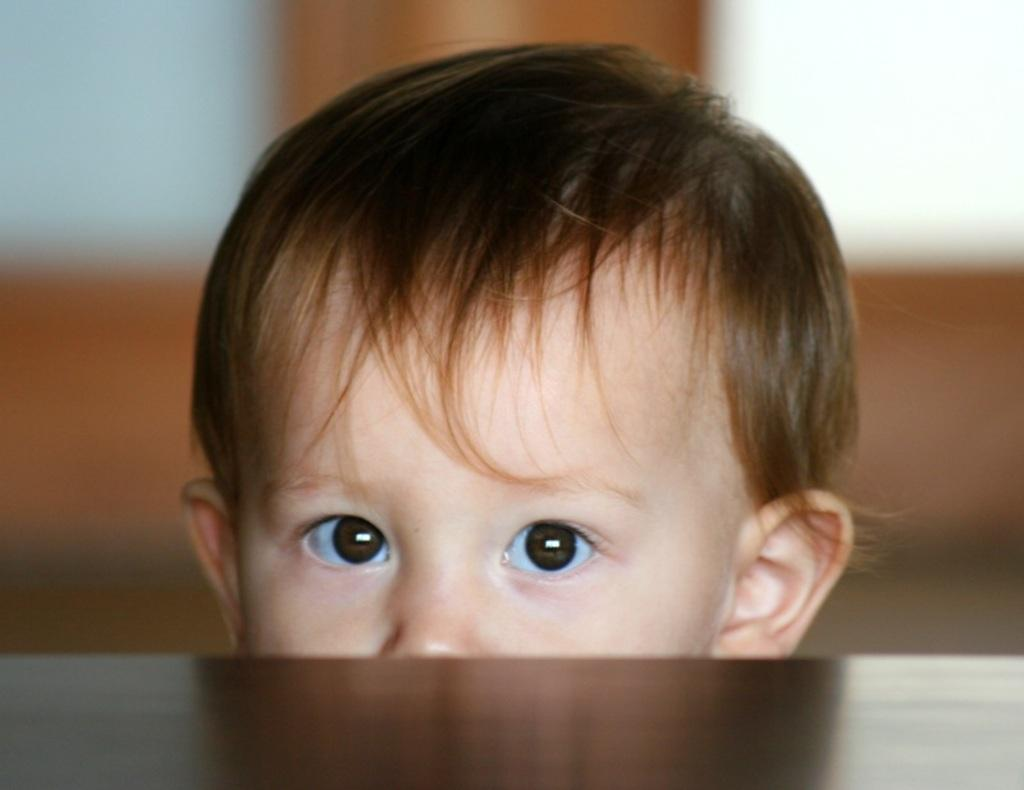What is the main subject of the image? The main subject of the image is a baby's face. Can you describe the background of the image? The background of the image is blurred. What type of advertisement is being displayed in the background of the image? There is no advertisement present in the image; the background is blurred. Can you see any pipes or roots in the image? There are no pipes or roots visible in the image; it features a baby's face with a blurred background. 